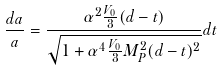Convert formula to latex. <formula><loc_0><loc_0><loc_500><loc_500>\frac { d a } { a } = \frac { \alpha ^ { 2 } \frac { V _ { 0 } } { 3 } ( d - t ) } { \sqrt { 1 + \alpha ^ { 4 } \frac { V _ { 0 } } { 3 } M _ { P } ^ { 2 } ( d - t ) ^ { 2 } } } d t</formula> 